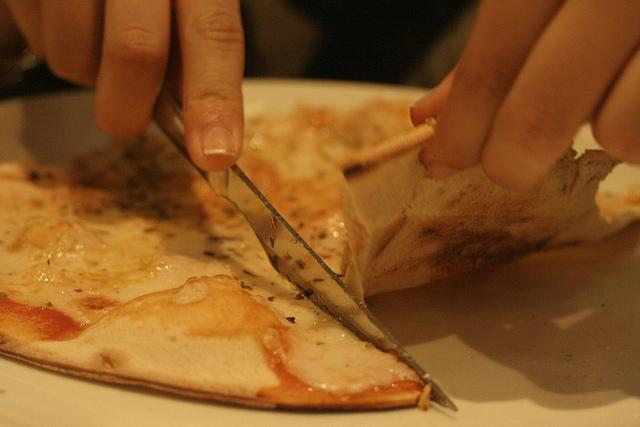What other utensil usually goes alongside the one shown?

Choices:
A) axe
B) spatula
C) fork
D) ladle fork 